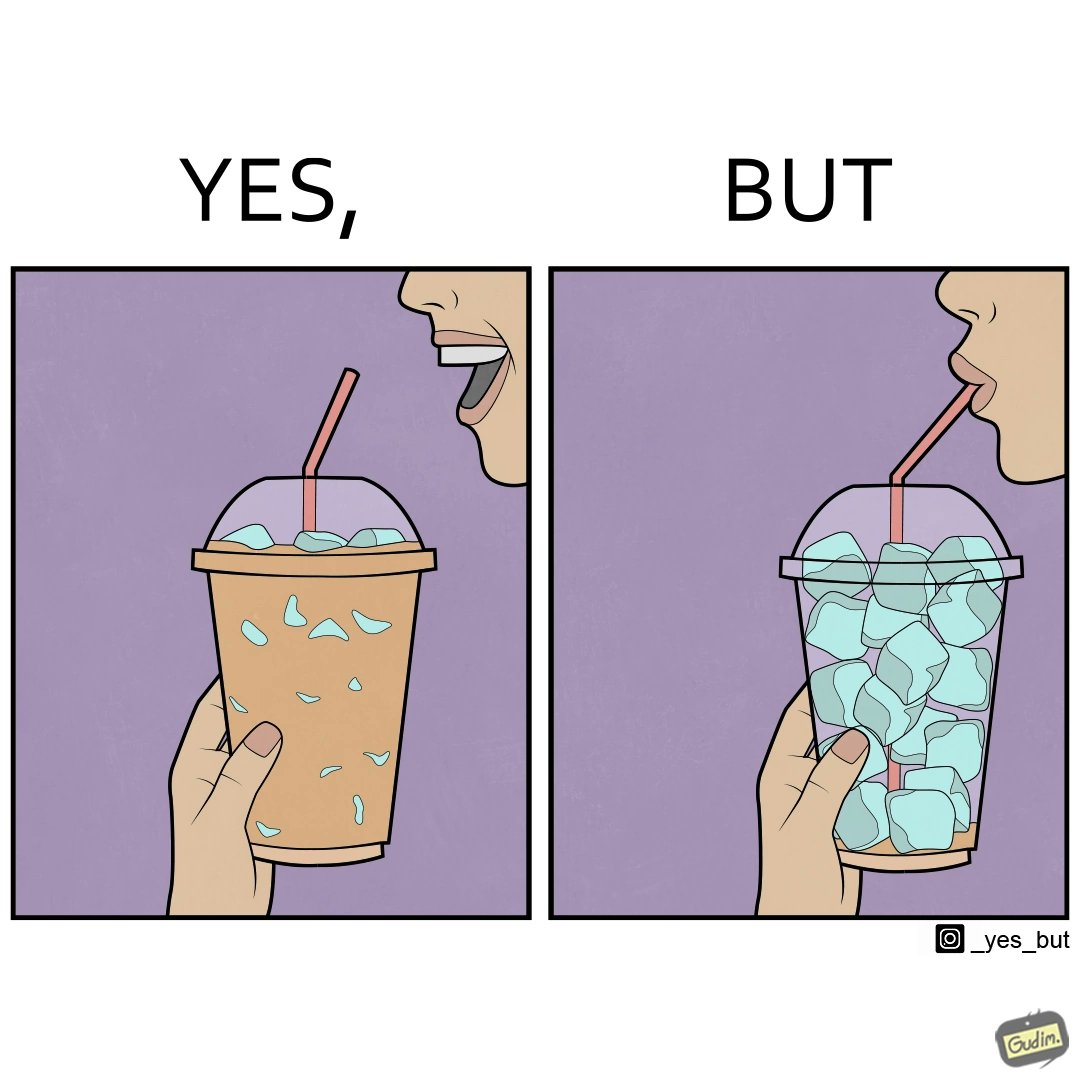Describe what you see in the left and right parts of this image. In the left part of the image: A person holding a drink with ice cubes, with a straw in the drink. In the right part of the image: A person drinking out of a straw from a drink. The drink is almost finished, and only I've cubes are left. 